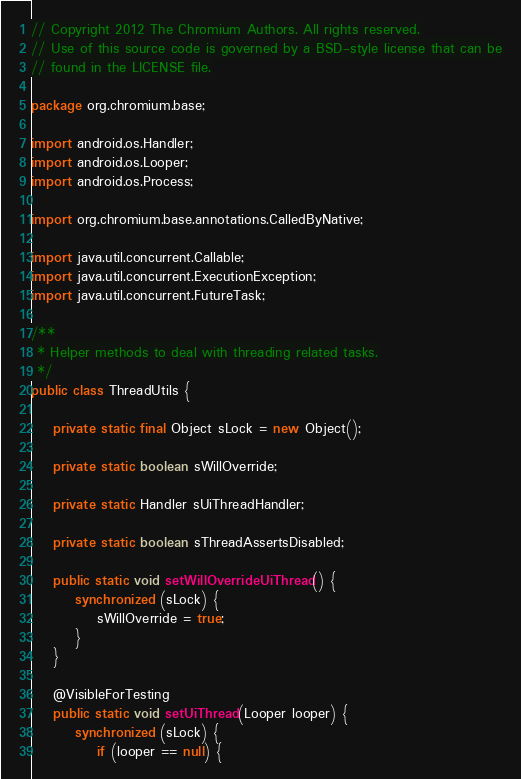<code> <loc_0><loc_0><loc_500><loc_500><_Java_>// Copyright 2012 The Chromium Authors. All rights reserved.
// Use of this source code is governed by a BSD-style license that can be
// found in the LICENSE file.

package org.chromium.base;

import android.os.Handler;
import android.os.Looper;
import android.os.Process;

import org.chromium.base.annotations.CalledByNative;

import java.util.concurrent.Callable;
import java.util.concurrent.ExecutionException;
import java.util.concurrent.FutureTask;

/**
 * Helper methods to deal with threading related tasks.
 */
public class ThreadUtils {

    private static final Object sLock = new Object();

    private static boolean sWillOverride;

    private static Handler sUiThreadHandler;

    private static boolean sThreadAssertsDisabled;

    public static void setWillOverrideUiThread() {
        synchronized (sLock) {
            sWillOverride = true;
        }
    }

    @VisibleForTesting
    public static void setUiThread(Looper looper) {
        synchronized (sLock) {
            if (looper == null) {</code> 